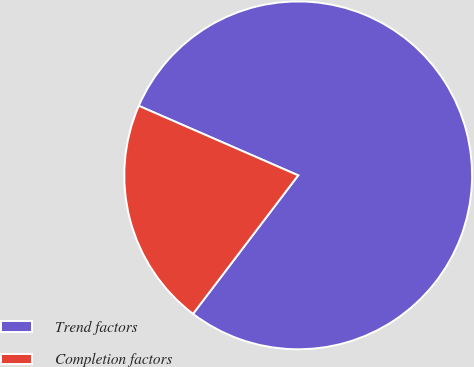Convert chart to OTSL. <chart><loc_0><loc_0><loc_500><loc_500><pie_chart><fcel>Trend factors<fcel>Completion factors<nl><fcel>78.79%<fcel>21.21%<nl></chart> 